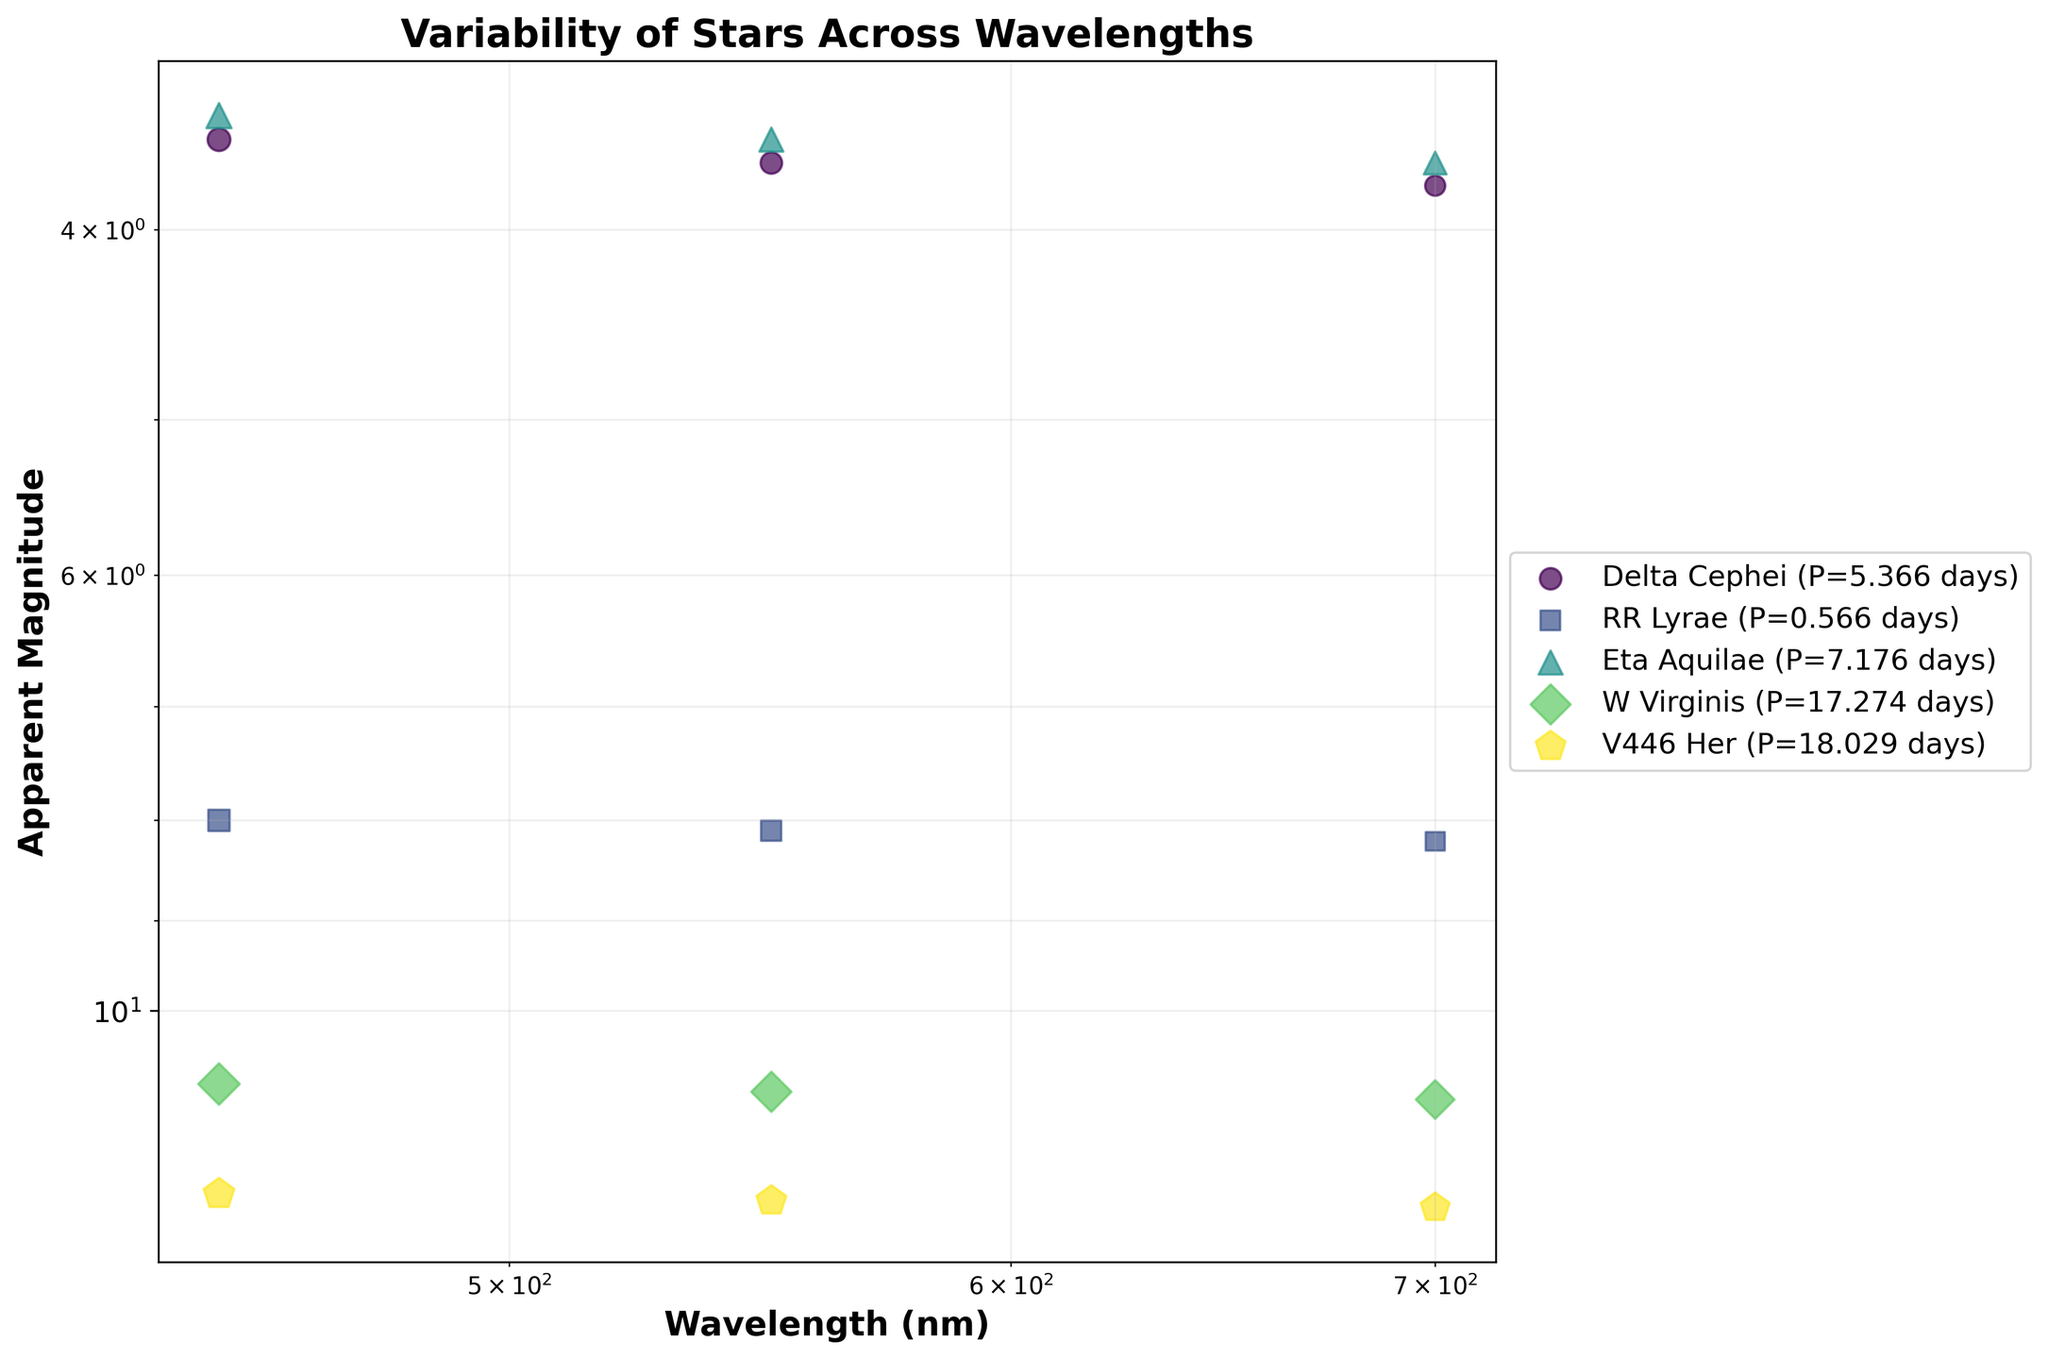What's the title of the plot? The title of the plot is displayed at the top of the figure. It helps to understand the main theme or subject of the plot. In this case, the title is "Variability of Stars Across Wavelengths".
Answer: Variability of Stars Across Wavelengths Which star has the largest amplitude at 450 nm? To find this, look at the plot's markers and identify the largest bubble at 450 nm wavelength. The size of the bubble represents the amplitude. The largest bubble corresponds to V446 Her.
Answer: V446 Her What is the common characteristic of all stars' apparent magnitudes as the wavelength increases? Observing the plot carefully, you can see that for all stars, the apparent magnitude increases (gets dimmer) as the wavelength increases, which can be identified by the positions of the markers and the y-axis scale.
Answer: Apparent magnitude increases Which star has the shortest period, and what is its period? By checking the legend, compare the period values associated with each star. RR Lyrae has the smallest period listed in the legend.
Answer: RR Lyrae; 0.566 days How does the amplitude of Delta Cephei change from 450 nm to 700 nm? Check the sizes of the markers for Delta Cephei across the different wavelengths. The size decreases from 450 nm (0.9) to 700 nm (0.7).
Answer: Decreases Which star has the highest apparent magnitude at 550 nm and what value it is? By looking at the y-axis corresponding to 550 nm, identify the star with the highest apparent magnitude (lowest position on the plot). W Virginis has the highest apparent magnitude at 11.0.
Answer: W Virginis; 11.0 Do all stars follow a similar trend regarding the change in their apparent magnitudes when observed at different wavelengths? Every star's apparent magnitude increases slightly as you move from left to right along the wavelength spectrum (logarithmic x-axis), representing an overall increasing trend. This indicates that magnitude increases (gets dimmer) with the wavelength.
Answer: Yes Compare the amplitude change from 450 nm to 700 nm for Eta Aquilae and W Virginis? By looking at the sizes of the markers at 450 nm and 700 nm for each star, compute the difference in sizes: Eta Aquilae decreases from 1.1 to 0.9, W Virginis decreases from 1.5 to 1.3. Eta Aquilae's change is 0.2, and W Virginis's change is 0.2.
Answer: Both decrease by 0.2 Which star has the most significant increase in apparent magnitude (change in y-value) across wavelengths? By analyzing the changes in apparent magnitudes (y-axis) across wavelengths for each star, V446 Her seems to have the most significant change from 12.4 to 12.6, but in terms of value impact W Virginis has a large absolute change from 10.9 to 11.1. Comparing these values, similar trend.
Answer: V446 Her /W Virginis have larger impact How do the variability periods compare between Cepheid and RR Lyrae variables? Compare the periods listed for the Cepheid stars (Delta Cephei, Eta Aquilae) and RR Lyrae. Cepheid periods are significantly longer (5.366, 7.176 days) than those for RR Lyrae (0.566 days).
Answer: Cepheid periods are longer 